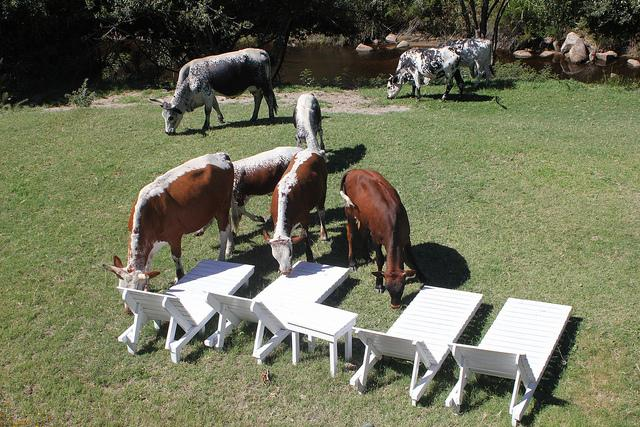What are the animals near? chairs 